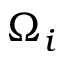Convert formula to latex. <formula><loc_0><loc_0><loc_500><loc_500>\Omega _ { i }</formula> 